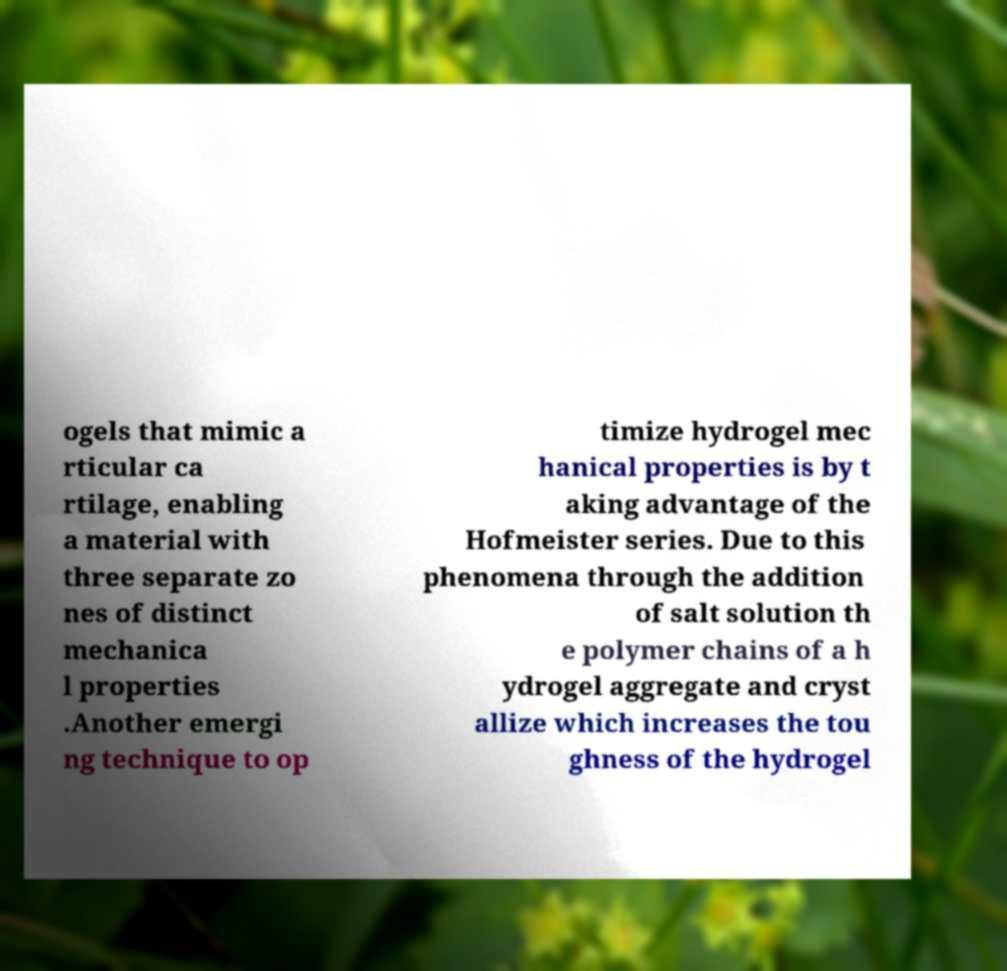Please read and relay the text visible in this image. What does it say? ogels that mimic a rticular ca rtilage, enabling a material with three separate zo nes of distinct mechanica l properties .Another emergi ng technique to op timize hydrogel mec hanical properties is by t aking advantage of the Hofmeister series. Due to this phenomena through the addition of salt solution th e polymer chains of a h ydrogel aggregate and cryst allize which increases the tou ghness of the hydrogel 